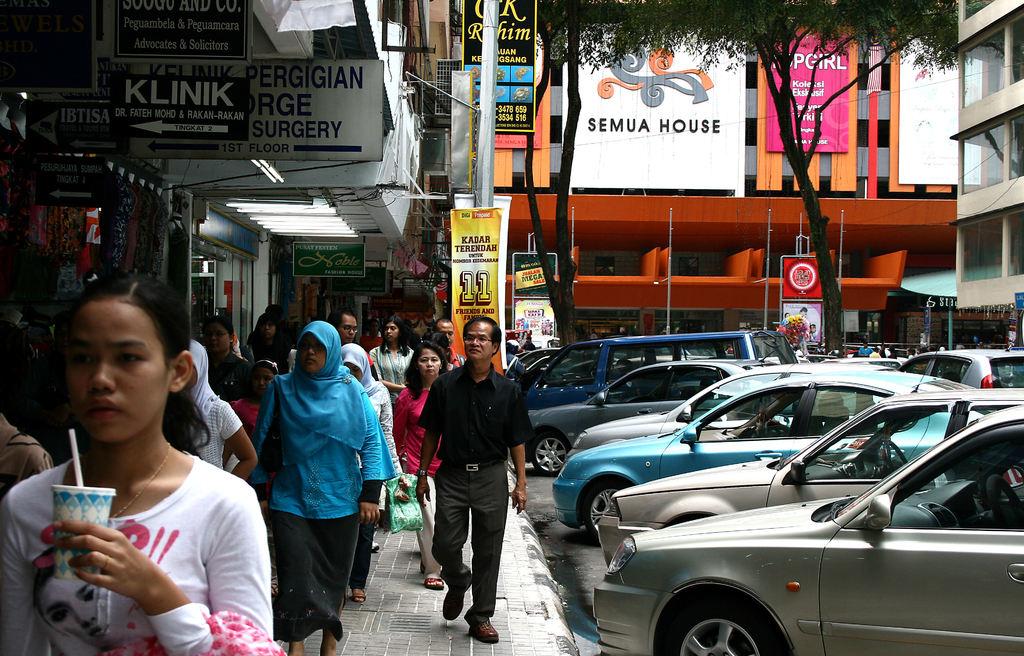What number is on the banner above the man in a black shirt?
Keep it short and to the point. 11. What is on the white sign in the middle of the back?
Your response must be concise. Semua house. 